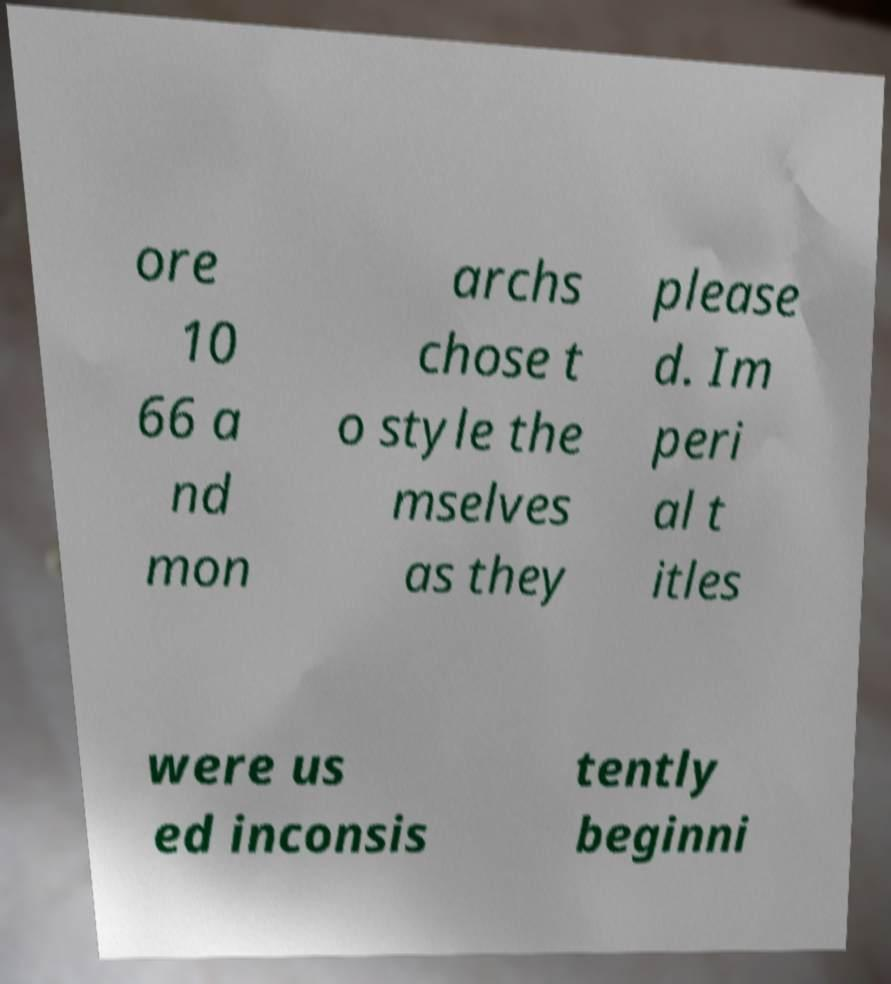There's text embedded in this image that I need extracted. Can you transcribe it verbatim? ore 10 66 a nd mon archs chose t o style the mselves as they please d. Im peri al t itles were us ed inconsis tently beginni 